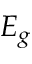Convert formula to latex. <formula><loc_0><loc_0><loc_500><loc_500>E _ { g }</formula> 